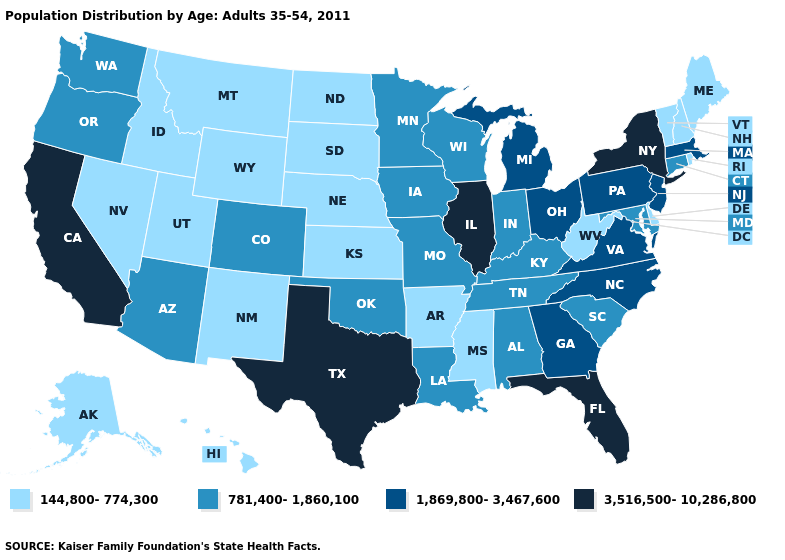Is the legend a continuous bar?
Write a very short answer. No. What is the value of Indiana?
Keep it brief. 781,400-1,860,100. What is the value of Maine?
Quick response, please. 144,800-774,300. What is the highest value in the USA?
Answer briefly. 3,516,500-10,286,800. What is the value of South Dakota?
Keep it brief. 144,800-774,300. What is the highest value in the South ?
Answer briefly. 3,516,500-10,286,800. What is the value of Arkansas?
Write a very short answer. 144,800-774,300. Does Connecticut have a lower value than Kansas?
Write a very short answer. No. Among the states that border California , which have the lowest value?
Answer briefly. Nevada. What is the value of Louisiana?
Be succinct. 781,400-1,860,100. Name the states that have a value in the range 3,516,500-10,286,800?
Be succinct. California, Florida, Illinois, New York, Texas. Name the states that have a value in the range 1,869,800-3,467,600?
Quick response, please. Georgia, Massachusetts, Michigan, New Jersey, North Carolina, Ohio, Pennsylvania, Virginia. Does Tennessee have the same value as New York?
Write a very short answer. No. Does Utah have the lowest value in the West?
Concise answer only. Yes. Name the states that have a value in the range 1,869,800-3,467,600?
Answer briefly. Georgia, Massachusetts, Michigan, New Jersey, North Carolina, Ohio, Pennsylvania, Virginia. 